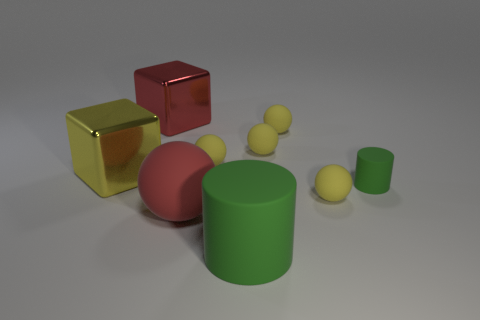What is the material of the ball that is both behind the red matte thing and on the left side of the big green thing?
Your answer should be very brief. Rubber. What size is the thing that is in front of the red thing that is to the right of the metal object that is behind the large yellow object?
Provide a succinct answer. Large. Are there more big red rubber objects than tiny brown cylinders?
Your answer should be very brief. Yes. Is the large block behind the large yellow cube made of the same material as the tiny cylinder?
Keep it short and to the point. No. Are there fewer large metal cylinders than small spheres?
Your answer should be compact. Yes. Is there a red object to the right of the large red thing in front of the small yellow ball in front of the small matte cylinder?
Make the answer very short. No. Is the shape of the red thing in front of the large yellow object the same as  the big red shiny thing?
Provide a succinct answer. No. Are there more yellow spheres in front of the tiny green thing than small yellow things?
Offer a terse response. No. Is the color of the thing that is in front of the red sphere the same as the small cylinder?
Your response must be concise. Yes. Are there any other things that have the same color as the large ball?
Provide a short and direct response. Yes. 